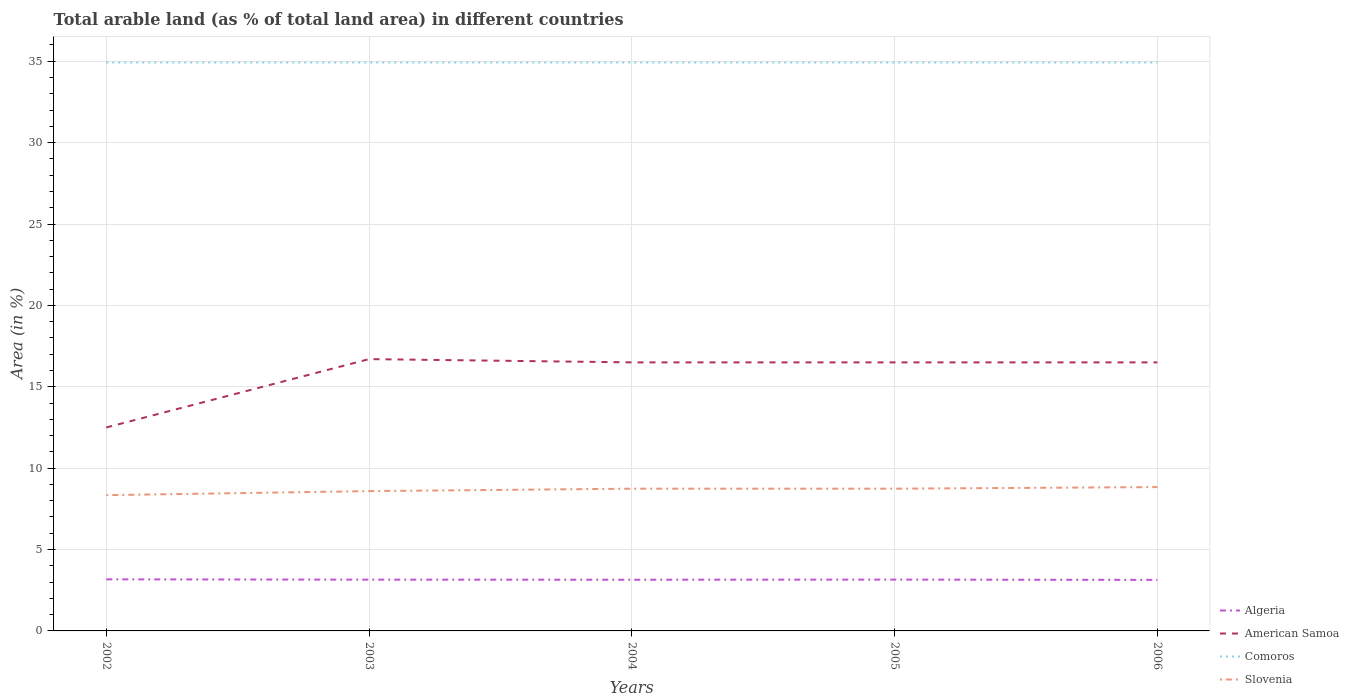How many different coloured lines are there?
Provide a succinct answer. 4. Does the line corresponding to Comoros intersect with the line corresponding to Slovenia?
Provide a short and direct response. No. Across all years, what is the maximum percentage of arable land in Comoros?
Your response must be concise. 34.93. In which year was the percentage of arable land in American Samoa maximum?
Provide a short and direct response. 2002. What is the total percentage of arable land in Comoros in the graph?
Your answer should be compact. 0. What is the difference between the highest and the second highest percentage of arable land in American Samoa?
Provide a succinct answer. 4.2. Does the graph contain any zero values?
Provide a short and direct response. No. Where does the legend appear in the graph?
Make the answer very short. Bottom right. How are the legend labels stacked?
Ensure brevity in your answer.  Vertical. What is the title of the graph?
Your answer should be very brief. Total arable land (as % of total land area) in different countries. Does "Cameroon" appear as one of the legend labels in the graph?
Provide a short and direct response. No. What is the label or title of the Y-axis?
Offer a very short reply. Area (in %). What is the Area (in %) in Algeria in 2002?
Offer a terse response. 3.17. What is the Area (in %) of American Samoa in 2002?
Give a very brief answer. 12.5. What is the Area (in %) of Comoros in 2002?
Provide a succinct answer. 34.93. What is the Area (in %) in Slovenia in 2002?
Your answer should be very brief. 8.34. What is the Area (in %) of Algeria in 2003?
Make the answer very short. 3.15. What is the Area (in %) in American Samoa in 2003?
Offer a terse response. 16.7. What is the Area (in %) in Comoros in 2003?
Provide a succinct answer. 34.93. What is the Area (in %) of Slovenia in 2003?
Provide a succinct answer. 8.59. What is the Area (in %) of Algeria in 2004?
Provide a succinct answer. 3.15. What is the Area (in %) in Comoros in 2004?
Give a very brief answer. 34.93. What is the Area (in %) in Slovenia in 2004?
Give a very brief answer. 8.74. What is the Area (in %) of Algeria in 2005?
Give a very brief answer. 3.15. What is the Area (in %) in American Samoa in 2005?
Offer a terse response. 16.5. What is the Area (in %) in Comoros in 2005?
Make the answer very short. 34.93. What is the Area (in %) of Slovenia in 2005?
Your response must be concise. 8.74. What is the Area (in %) of Algeria in 2006?
Your answer should be compact. 3.14. What is the Area (in %) in American Samoa in 2006?
Make the answer very short. 16.5. What is the Area (in %) in Comoros in 2006?
Provide a succinct answer. 34.93. What is the Area (in %) of Slovenia in 2006?
Offer a very short reply. 8.84. Across all years, what is the maximum Area (in %) of Algeria?
Your response must be concise. 3.17. Across all years, what is the maximum Area (in %) of Comoros?
Make the answer very short. 34.93. Across all years, what is the maximum Area (in %) in Slovenia?
Give a very brief answer. 8.84. Across all years, what is the minimum Area (in %) of Algeria?
Offer a terse response. 3.14. Across all years, what is the minimum Area (in %) in Comoros?
Ensure brevity in your answer.  34.93. Across all years, what is the minimum Area (in %) of Slovenia?
Make the answer very short. 8.34. What is the total Area (in %) of Algeria in the graph?
Provide a short and direct response. 15.76. What is the total Area (in %) of American Samoa in the graph?
Provide a succinct answer. 78.7. What is the total Area (in %) of Comoros in the graph?
Keep it short and to the point. 174.64. What is the total Area (in %) of Slovenia in the graph?
Offer a very short reply. 43.25. What is the difference between the Area (in %) of Algeria in 2002 and that in 2003?
Give a very brief answer. 0.02. What is the difference between the Area (in %) in American Samoa in 2002 and that in 2003?
Keep it short and to the point. -4.2. What is the difference between the Area (in %) of Comoros in 2002 and that in 2003?
Make the answer very short. 0. What is the difference between the Area (in %) of Slovenia in 2002 and that in 2003?
Your answer should be very brief. -0.25. What is the difference between the Area (in %) of Algeria in 2002 and that in 2004?
Provide a short and direct response. 0.02. What is the difference between the Area (in %) of American Samoa in 2002 and that in 2004?
Your answer should be very brief. -4. What is the difference between the Area (in %) in Slovenia in 2002 and that in 2004?
Provide a succinct answer. -0.4. What is the difference between the Area (in %) of Algeria in 2002 and that in 2005?
Provide a succinct answer. 0.02. What is the difference between the Area (in %) of Comoros in 2002 and that in 2005?
Make the answer very short. 0. What is the difference between the Area (in %) of Slovenia in 2002 and that in 2005?
Offer a very short reply. -0.4. What is the difference between the Area (in %) of Algeria in 2002 and that in 2006?
Your response must be concise. 0.03. What is the difference between the Area (in %) of Slovenia in 2002 and that in 2006?
Ensure brevity in your answer.  -0.5. What is the difference between the Area (in %) in Algeria in 2003 and that in 2004?
Provide a short and direct response. 0. What is the difference between the Area (in %) in Slovenia in 2003 and that in 2004?
Provide a succinct answer. -0.15. What is the difference between the Area (in %) of Algeria in 2003 and that in 2005?
Your response must be concise. -0. What is the difference between the Area (in %) in American Samoa in 2003 and that in 2005?
Offer a terse response. 0.2. What is the difference between the Area (in %) in Slovenia in 2003 and that in 2005?
Provide a succinct answer. -0.15. What is the difference between the Area (in %) in Algeria in 2003 and that in 2006?
Provide a short and direct response. 0.01. What is the difference between the Area (in %) in American Samoa in 2003 and that in 2006?
Offer a very short reply. 0.2. What is the difference between the Area (in %) of Comoros in 2003 and that in 2006?
Make the answer very short. 0. What is the difference between the Area (in %) in Slovenia in 2003 and that in 2006?
Keep it short and to the point. -0.25. What is the difference between the Area (in %) in Algeria in 2004 and that in 2005?
Keep it short and to the point. -0.01. What is the difference between the Area (in %) of Algeria in 2004 and that in 2006?
Offer a very short reply. 0.01. What is the difference between the Area (in %) of Slovenia in 2004 and that in 2006?
Your response must be concise. -0.1. What is the difference between the Area (in %) in Algeria in 2005 and that in 2006?
Your response must be concise. 0.02. What is the difference between the Area (in %) of Slovenia in 2005 and that in 2006?
Provide a short and direct response. -0.1. What is the difference between the Area (in %) of Algeria in 2002 and the Area (in %) of American Samoa in 2003?
Your answer should be very brief. -13.53. What is the difference between the Area (in %) in Algeria in 2002 and the Area (in %) in Comoros in 2003?
Ensure brevity in your answer.  -31.76. What is the difference between the Area (in %) in Algeria in 2002 and the Area (in %) in Slovenia in 2003?
Provide a short and direct response. -5.42. What is the difference between the Area (in %) in American Samoa in 2002 and the Area (in %) in Comoros in 2003?
Provide a short and direct response. -22.43. What is the difference between the Area (in %) of American Samoa in 2002 and the Area (in %) of Slovenia in 2003?
Provide a short and direct response. 3.91. What is the difference between the Area (in %) of Comoros in 2002 and the Area (in %) of Slovenia in 2003?
Offer a terse response. 26.34. What is the difference between the Area (in %) of Algeria in 2002 and the Area (in %) of American Samoa in 2004?
Your answer should be compact. -13.33. What is the difference between the Area (in %) in Algeria in 2002 and the Area (in %) in Comoros in 2004?
Give a very brief answer. -31.76. What is the difference between the Area (in %) in Algeria in 2002 and the Area (in %) in Slovenia in 2004?
Make the answer very short. -5.57. What is the difference between the Area (in %) of American Samoa in 2002 and the Area (in %) of Comoros in 2004?
Your answer should be compact. -22.43. What is the difference between the Area (in %) in American Samoa in 2002 and the Area (in %) in Slovenia in 2004?
Provide a short and direct response. 3.76. What is the difference between the Area (in %) of Comoros in 2002 and the Area (in %) of Slovenia in 2004?
Ensure brevity in your answer.  26.19. What is the difference between the Area (in %) of Algeria in 2002 and the Area (in %) of American Samoa in 2005?
Your answer should be very brief. -13.33. What is the difference between the Area (in %) in Algeria in 2002 and the Area (in %) in Comoros in 2005?
Provide a short and direct response. -31.76. What is the difference between the Area (in %) of Algeria in 2002 and the Area (in %) of Slovenia in 2005?
Give a very brief answer. -5.57. What is the difference between the Area (in %) in American Samoa in 2002 and the Area (in %) in Comoros in 2005?
Provide a succinct answer. -22.43. What is the difference between the Area (in %) in American Samoa in 2002 and the Area (in %) in Slovenia in 2005?
Your answer should be very brief. 3.76. What is the difference between the Area (in %) of Comoros in 2002 and the Area (in %) of Slovenia in 2005?
Ensure brevity in your answer.  26.19. What is the difference between the Area (in %) of Algeria in 2002 and the Area (in %) of American Samoa in 2006?
Keep it short and to the point. -13.33. What is the difference between the Area (in %) of Algeria in 2002 and the Area (in %) of Comoros in 2006?
Offer a terse response. -31.76. What is the difference between the Area (in %) in Algeria in 2002 and the Area (in %) in Slovenia in 2006?
Ensure brevity in your answer.  -5.67. What is the difference between the Area (in %) in American Samoa in 2002 and the Area (in %) in Comoros in 2006?
Your answer should be compact. -22.43. What is the difference between the Area (in %) of American Samoa in 2002 and the Area (in %) of Slovenia in 2006?
Your answer should be compact. 3.66. What is the difference between the Area (in %) of Comoros in 2002 and the Area (in %) of Slovenia in 2006?
Provide a short and direct response. 26.09. What is the difference between the Area (in %) of Algeria in 2003 and the Area (in %) of American Samoa in 2004?
Your answer should be compact. -13.35. What is the difference between the Area (in %) in Algeria in 2003 and the Area (in %) in Comoros in 2004?
Offer a terse response. -31.78. What is the difference between the Area (in %) of Algeria in 2003 and the Area (in %) of Slovenia in 2004?
Offer a terse response. -5.59. What is the difference between the Area (in %) of American Samoa in 2003 and the Area (in %) of Comoros in 2004?
Your answer should be very brief. -18.23. What is the difference between the Area (in %) of American Samoa in 2003 and the Area (in %) of Slovenia in 2004?
Keep it short and to the point. 7.96. What is the difference between the Area (in %) in Comoros in 2003 and the Area (in %) in Slovenia in 2004?
Offer a very short reply. 26.19. What is the difference between the Area (in %) in Algeria in 2003 and the Area (in %) in American Samoa in 2005?
Provide a succinct answer. -13.35. What is the difference between the Area (in %) of Algeria in 2003 and the Area (in %) of Comoros in 2005?
Provide a short and direct response. -31.78. What is the difference between the Area (in %) of Algeria in 2003 and the Area (in %) of Slovenia in 2005?
Provide a short and direct response. -5.59. What is the difference between the Area (in %) of American Samoa in 2003 and the Area (in %) of Comoros in 2005?
Ensure brevity in your answer.  -18.23. What is the difference between the Area (in %) of American Samoa in 2003 and the Area (in %) of Slovenia in 2005?
Make the answer very short. 7.96. What is the difference between the Area (in %) in Comoros in 2003 and the Area (in %) in Slovenia in 2005?
Make the answer very short. 26.19. What is the difference between the Area (in %) of Algeria in 2003 and the Area (in %) of American Samoa in 2006?
Offer a terse response. -13.35. What is the difference between the Area (in %) of Algeria in 2003 and the Area (in %) of Comoros in 2006?
Provide a succinct answer. -31.78. What is the difference between the Area (in %) in Algeria in 2003 and the Area (in %) in Slovenia in 2006?
Give a very brief answer. -5.69. What is the difference between the Area (in %) of American Samoa in 2003 and the Area (in %) of Comoros in 2006?
Your answer should be compact. -18.23. What is the difference between the Area (in %) in American Samoa in 2003 and the Area (in %) in Slovenia in 2006?
Your answer should be compact. 7.86. What is the difference between the Area (in %) in Comoros in 2003 and the Area (in %) in Slovenia in 2006?
Provide a succinct answer. 26.09. What is the difference between the Area (in %) in Algeria in 2004 and the Area (in %) in American Samoa in 2005?
Provide a succinct answer. -13.35. What is the difference between the Area (in %) in Algeria in 2004 and the Area (in %) in Comoros in 2005?
Offer a very short reply. -31.78. What is the difference between the Area (in %) of Algeria in 2004 and the Area (in %) of Slovenia in 2005?
Keep it short and to the point. -5.59. What is the difference between the Area (in %) in American Samoa in 2004 and the Area (in %) in Comoros in 2005?
Make the answer very short. -18.43. What is the difference between the Area (in %) in American Samoa in 2004 and the Area (in %) in Slovenia in 2005?
Ensure brevity in your answer.  7.76. What is the difference between the Area (in %) of Comoros in 2004 and the Area (in %) of Slovenia in 2005?
Provide a succinct answer. 26.19. What is the difference between the Area (in %) in Algeria in 2004 and the Area (in %) in American Samoa in 2006?
Ensure brevity in your answer.  -13.35. What is the difference between the Area (in %) in Algeria in 2004 and the Area (in %) in Comoros in 2006?
Give a very brief answer. -31.78. What is the difference between the Area (in %) in Algeria in 2004 and the Area (in %) in Slovenia in 2006?
Give a very brief answer. -5.69. What is the difference between the Area (in %) in American Samoa in 2004 and the Area (in %) in Comoros in 2006?
Your answer should be compact. -18.43. What is the difference between the Area (in %) in American Samoa in 2004 and the Area (in %) in Slovenia in 2006?
Give a very brief answer. 7.66. What is the difference between the Area (in %) in Comoros in 2004 and the Area (in %) in Slovenia in 2006?
Offer a very short reply. 26.09. What is the difference between the Area (in %) in Algeria in 2005 and the Area (in %) in American Samoa in 2006?
Keep it short and to the point. -13.35. What is the difference between the Area (in %) in Algeria in 2005 and the Area (in %) in Comoros in 2006?
Keep it short and to the point. -31.77. What is the difference between the Area (in %) of Algeria in 2005 and the Area (in %) of Slovenia in 2006?
Offer a very short reply. -5.68. What is the difference between the Area (in %) in American Samoa in 2005 and the Area (in %) in Comoros in 2006?
Offer a very short reply. -18.43. What is the difference between the Area (in %) of American Samoa in 2005 and the Area (in %) of Slovenia in 2006?
Your response must be concise. 7.66. What is the difference between the Area (in %) in Comoros in 2005 and the Area (in %) in Slovenia in 2006?
Make the answer very short. 26.09. What is the average Area (in %) of Algeria per year?
Your response must be concise. 3.15. What is the average Area (in %) in American Samoa per year?
Your response must be concise. 15.74. What is the average Area (in %) in Comoros per year?
Your answer should be compact. 34.93. What is the average Area (in %) of Slovenia per year?
Provide a short and direct response. 8.65. In the year 2002, what is the difference between the Area (in %) in Algeria and Area (in %) in American Samoa?
Give a very brief answer. -9.33. In the year 2002, what is the difference between the Area (in %) of Algeria and Area (in %) of Comoros?
Make the answer very short. -31.76. In the year 2002, what is the difference between the Area (in %) in Algeria and Area (in %) in Slovenia?
Provide a succinct answer. -5.17. In the year 2002, what is the difference between the Area (in %) of American Samoa and Area (in %) of Comoros?
Offer a terse response. -22.43. In the year 2002, what is the difference between the Area (in %) of American Samoa and Area (in %) of Slovenia?
Ensure brevity in your answer.  4.16. In the year 2002, what is the difference between the Area (in %) of Comoros and Area (in %) of Slovenia?
Give a very brief answer. 26.59. In the year 2003, what is the difference between the Area (in %) in Algeria and Area (in %) in American Samoa?
Offer a terse response. -13.55. In the year 2003, what is the difference between the Area (in %) in Algeria and Area (in %) in Comoros?
Offer a very short reply. -31.78. In the year 2003, what is the difference between the Area (in %) in Algeria and Area (in %) in Slovenia?
Give a very brief answer. -5.44. In the year 2003, what is the difference between the Area (in %) of American Samoa and Area (in %) of Comoros?
Offer a very short reply. -18.23. In the year 2003, what is the difference between the Area (in %) of American Samoa and Area (in %) of Slovenia?
Make the answer very short. 8.11. In the year 2003, what is the difference between the Area (in %) in Comoros and Area (in %) in Slovenia?
Offer a very short reply. 26.34. In the year 2004, what is the difference between the Area (in %) in Algeria and Area (in %) in American Samoa?
Your answer should be very brief. -13.35. In the year 2004, what is the difference between the Area (in %) of Algeria and Area (in %) of Comoros?
Your response must be concise. -31.78. In the year 2004, what is the difference between the Area (in %) of Algeria and Area (in %) of Slovenia?
Your answer should be very brief. -5.59. In the year 2004, what is the difference between the Area (in %) of American Samoa and Area (in %) of Comoros?
Keep it short and to the point. -18.43. In the year 2004, what is the difference between the Area (in %) in American Samoa and Area (in %) in Slovenia?
Give a very brief answer. 7.76. In the year 2004, what is the difference between the Area (in %) of Comoros and Area (in %) of Slovenia?
Keep it short and to the point. 26.19. In the year 2005, what is the difference between the Area (in %) in Algeria and Area (in %) in American Samoa?
Ensure brevity in your answer.  -13.35. In the year 2005, what is the difference between the Area (in %) in Algeria and Area (in %) in Comoros?
Ensure brevity in your answer.  -31.77. In the year 2005, what is the difference between the Area (in %) in Algeria and Area (in %) in Slovenia?
Your answer should be compact. -5.59. In the year 2005, what is the difference between the Area (in %) in American Samoa and Area (in %) in Comoros?
Make the answer very short. -18.43. In the year 2005, what is the difference between the Area (in %) in American Samoa and Area (in %) in Slovenia?
Offer a very short reply. 7.76. In the year 2005, what is the difference between the Area (in %) in Comoros and Area (in %) in Slovenia?
Offer a very short reply. 26.19. In the year 2006, what is the difference between the Area (in %) of Algeria and Area (in %) of American Samoa?
Ensure brevity in your answer.  -13.36. In the year 2006, what is the difference between the Area (in %) of Algeria and Area (in %) of Comoros?
Provide a short and direct response. -31.79. In the year 2006, what is the difference between the Area (in %) in Algeria and Area (in %) in Slovenia?
Keep it short and to the point. -5.7. In the year 2006, what is the difference between the Area (in %) of American Samoa and Area (in %) of Comoros?
Ensure brevity in your answer.  -18.43. In the year 2006, what is the difference between the Area (in %) of American Samoa and Area (in %) of Slovenia?
Your response must be concise. 7.66. In the year 2006, what is the difference between the Area (in %) in Comoros and Area (in %) in Slovenia?
Offer a very short reply. 26.09. What is the ratio of the Area (in %) in Algeria in 2002 to that in 2003?
Give a very brief answer. 1.01. What is the ratio of the Area (in %) of American Samoa in 2002 to that in 2003?
Ensure brevity in your answer.  0.75. What is the ratio of the Area (in %) in Slovenia in 2002 to that in 2003?
Make the answer very short. 0.97. What is the ratio of the Area (in %) of Algeria in 2002 to that in 2004?
Offer a very short reply. 1.01. What is the ratio of the Area (in %) of American Samoa in 2002 to that in 2004?
Keep it short and to the point. 0.76. What is the ratio of the Area (in %) of Slovenia in 2002 to that in 2004?
Offer a very short reply. 0.95. What is the ratio of the Area (in %) of Algeria in 2002 to that in 2005?
Make the answer very short. 1. What is the ratio of the Area (in %) in American Samoa in 2002 to that in 2005?
Provide a short and direct response. 0.76. What is the ratio of the Area (in %) in Comoros in 2002 to that in 2005?
Ensure brevity in your answer.  1. What is the ratio of the Area (in %) of Slovenia in 2002 to that in 2005?
Offer a very short reply. 0.95. What is the ratio of the Area (in %) in Algeria in 2002 to that in 2006?
Provide a succinct answer. 1.01. What is the ratio of the Area (in %) in American Samoa in 2002 to that in 2006?
Your answer should be compact. 0.76. What is the ratio of the Area (in %) in Comoros in 2002 to that in 2006?
Provide a succinct answer. 1. What is the ratio of the Area (in %) in Slovenia in 2002 to that in 2006?
Keep it short and to the point. 0.94. What is the ratio of the Area (in %) in Algeria in 2003 to that in 2004?
Your answer should be compact. 1. What is the ratio of the Area (in %) in American Samoa in 2003 to that in 2004?
Ensure brevity in your answer.  1.01. What is the ratio of the Area (in %) of Slovenia in 2003 to that in 2004?
Provide a short and direct response. 0.98. What is the ratio of the Area (in %) of Algeria in 2003 to that in 2005?
Provide a short and direct response. 1. What is the ratio of the Area (in %) in American Samoa in 2003 to that in 2005?
Your answer should be very brief. 1.01. What is the ratio of the Area (in %) in Comoros in 2003 to that in 2005?
Provide a short and direct response. 1. What is the ratio of the Area (in %) of Algeria in 2003 to that in 2006?
Ensure brevity in your answer.  1. What is the ratio of the Area (in %) in American Samoa in 2003 to that in 2006?
Ensure brevity in your answer.  1.01. What is the ratio of the Area (in %) of Comoros in 2003 to that in 2006?
Ensure brevity in your answer.  1. What is the ratio of the Area (in %) of Slovenia in 2003 to that in 2006?
Ensure brevity in your answer.  0.97. What is the ratio of the Area (in %) of Algeria in 2004 to that in 2005?
Make the answer very short. 1. What is the ratio of the Area (in %) in American Samoa in 2004 to that in 2005?
Your answer should be very brief. 1. What is the ratio of the Area (in %) in Comoros in 2004 to that in 2005?
Keep it short and to the point. 1. What is the ratio of the Area (in %) of Slovenia in 2004 to that in 2005?
Make the answer very short. 1. What is the ratio of the Area (in %) of American Samoa in 2004 to that in 2006?
Provide a succinct answer. 1. What is the ratio of the Area (in %) of Comoros in 2004 to that in 2006?
Provide a succinct answer. 1. What is the difference between the highest and the second highest Area (in %) of Algeria?
Give a very brief answer. 0.02. What is the difference between the highest and the second highest Area (in %) in American Samoa?
Give a very brief answer. 0.2. What is the difference between the highest and the second highest Area (in %) of Comoros?
Your answer should be compact. 0. What is the difference between the highest and the second highest Area (in %) in Slovenia?
Make the answer very short. 0.1. What is the difference between the highest and the lowest Area (in %) of Algeria?
Give a very brief answer. 0.03. What is the difference between the highest and the lowest Area (in %) in American Samoa?
Offer a terse response. 4.2. What is the difference between the highest and the lowest Area (in %) in Comoros?
Your response must be concise. 0. What is the difference between the highest and the lowest Area (in %) of Slovenia?
Make the answer very short. 0.5. 